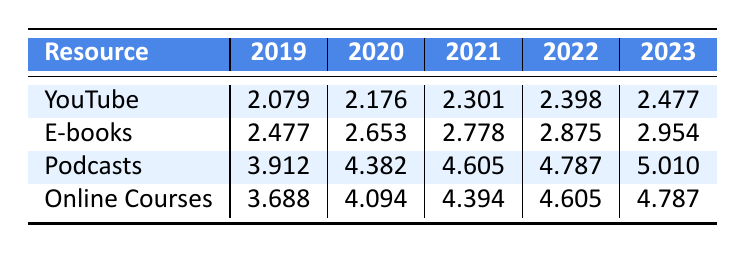What was the logarithmic value for Podcasts in 2021? The table shows the resource "Podcasts" in the column for the year 2021, which has a logarithmic value of 4.605.
Answer: 4.605 Which resource had the highest logarithmic value in 2023? Looking at the 2023 column, Podcasts has a logarithmic value of 5.010, which is the highest compared to the other resources.
Answer: Podcasts What is the difference in the logarithmic value for YouTube between 2019 and 2023? The logarithmic value for YouTube in 2019 is 2.079 and in 2023 is 2.477. The difference is calculated as 2.477 - 2.079 = 0.398.
Answer: 0.398 Is the logarithmic value for E-books higher in 2022 than in 2021? In the table, the logarithmic value for E-books in 2022 is 2.875 and in 2021 is 2.778. Since 2.875 is greater than 2.778, the statement is true.
Answer: Yes What is the average logarithmic value for Online Courses over the five years? The logarithmic values for Online Courses from 2019 to 2023 are 3.688, 4.094, 4.394, 4.605, and 4.787. To find the average: (3.688 + 4.094 + 4.394 + 4.605 + 4.787) / 5 = 4.1136.
Answer: 4.1136 How much did the logarithmic value for Podcasts increase from 2019 to 2022? The logarithmic value for Podcasts in 2019 is 3.912, and in 2022 it is 4.787. The increase is calculated as 4.787 - 3.912 = 0.875.
Answer: 0.875 Was the logarithmic value for YouTube in 2020 greater than that for Online Courses in 2019? The logarithmic value for YouTube in 2020 is 2.176, and for Online Courses in 2019 is 3.688. Since 2.176 is less than 3.688, the statement is false.
Answer: No What resource experienced the highest growth in logarithmic value from 2019 to 2023? To determine growth, we look at the difference between the first and last years for each resource. YouTube: 2.477 - 2.079 = 0.398, E-books: 2.954 - 2.477 = 0.477, Podcasts: 5.010 - 3.912 = 1.098, Online Courses: 4.787 - 3.688 = 1.099. Online Courses experienced the highest growth by 1.099.
Answer: Online Courses 